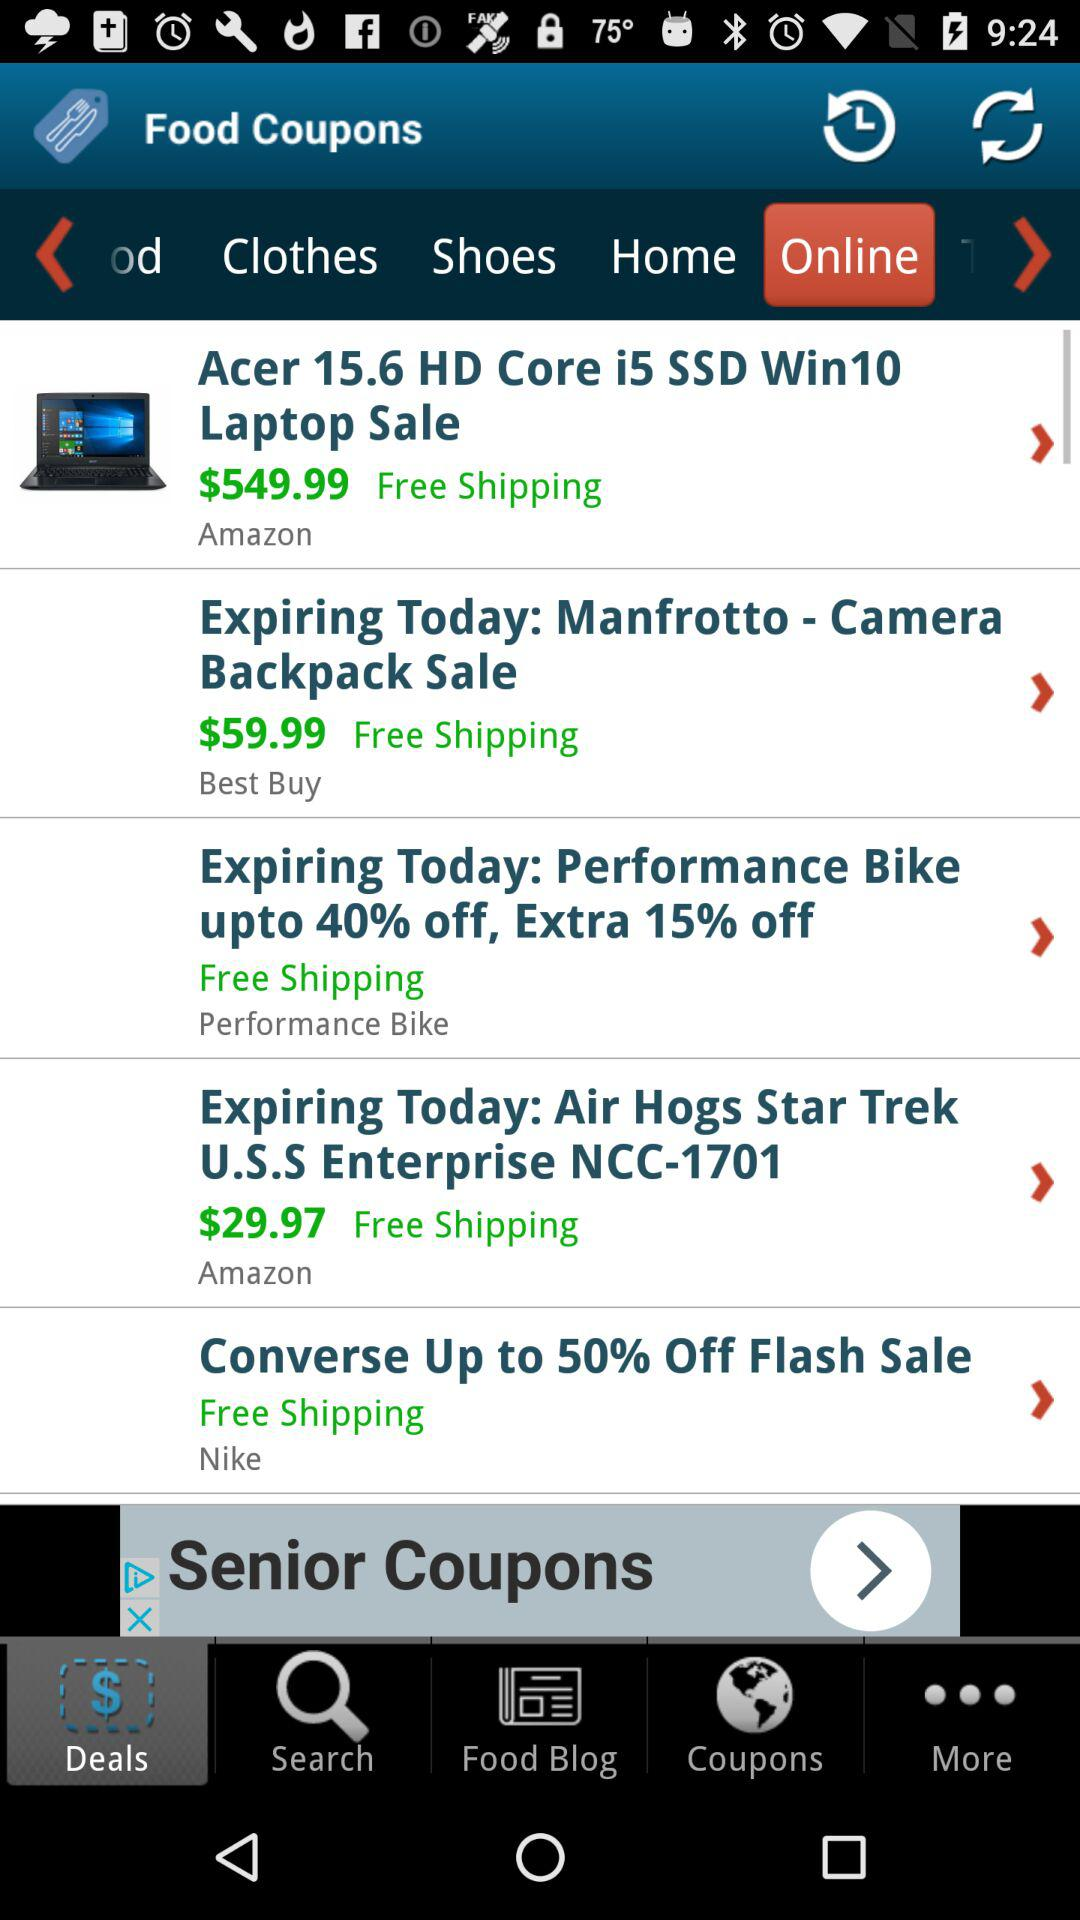What is the price of the "Air Hogs Star Trek U.S.S Enterprise"? The price of the "Air Hogs Star Trek U.S.S Enterprise" is $29.97. 